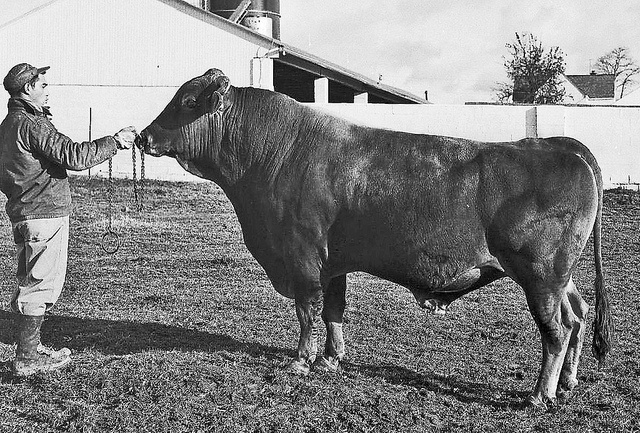Describe the objects in this image and their specific colors. I can see cow in lightgray, black, gray, and darkgray tones and people in lightgray, gray, black, and darkgray tones in this image. 